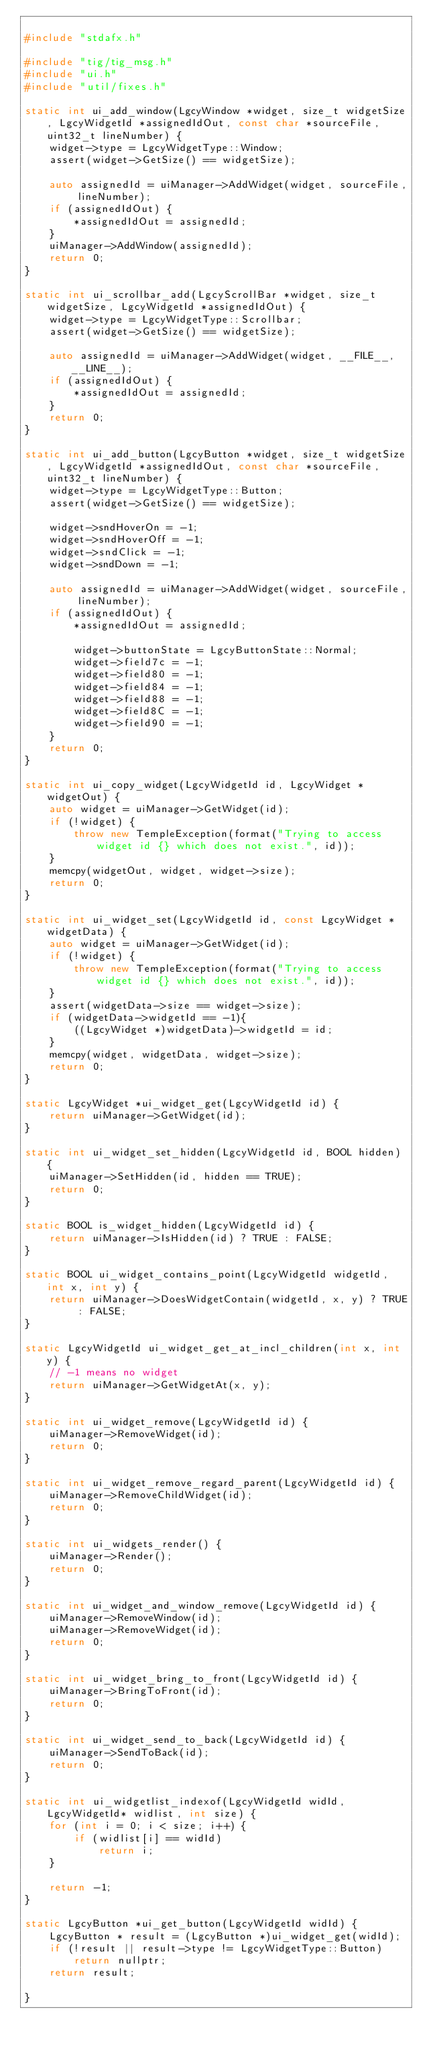Convert code to text. <code><loc_0><loc_0><loc_500><loc_500><_C++_>
#include "stdafx.h"

#include "tig/tig_msg.h"
#include "ui.h"
#include "util/fixes.h"

static int ui_add_window(LgcyWindow *widget, size_t widgetSize, LgcyWidgetId *assignedIdOut, const char *sourceFile, uint32_t lineNumber) {
	widget->type = LgcyWidgetType::Window;
	assert(widget->GetSize() == widgetSize);
	
	auto assignedId = uiManager->AddWidget(widget, sourceFile, lineNumber);
	if (assignedIdOut) {
		*assignedIdOut = assignedId;
	}
	uiManager->AddWindow(assignedId);
	return 0;
}

static int ui_scrollbar_add(LgcyScrollBar *widget, size_t widgetSize, LgcyWidgetId *assignedIdOut) {
	widget->type = LgcyWidgetType::Scrollbar;
	assert(widget->GetSize() == widgetSize);

	auto assignedId = uiManager->AddWidget(widget, __FILE__, __LINE__);
	if (assignedIdOut) {
		*assignedIdOut = assignedId;
	}
	return 0;
}

static int ui_add_button(LgcyButton *widget, size_t widgetSize, LgcyWidgetId *assignedIdOut, const char *sourceFile, uint32_t lineNumber) {
	widget->type = LgcyWidgetType::Button;
	assert(widget->GetSize() == widgetSize);

	widget->sndHoverOn = -1;
	widget->sndHoverOff = -1;
	widget->sndClick = -1;
	widget->sndDown = -1;

	auto assignedId = uiManager->AddWidget(widget, sourceFile, lineNumber);
	if (assignedIdOut) {
		*assignedIdOut = assignedId;

		widget->buttonState = LgcyButtonState::Normal;
		widget->field7c = -1;
		widget->field80 = -1;
		widget->field84 = -1;
		widget->field88 = -1;
		widget->field8C = -1;
		widget->field90 = -1;
	}
	return 0;
}

static int ui_copy_widget(LgcyWidgetId id, LgcyWidget *widgetOut) {
	auto widget = uiManager->GetWidget(id);
	if (!widget) {
		throw new TempleException(format("Trying to access widget id {} which does not exist.", id));
	}
	memcpy(widgetOut, widget, widget->size);
	return 0;
}

static int ui_widget_set(LgcyWidgetId id, const LgcyWidget *widgetData) {
	auto widget = uiManager->GetWidget(id);
	if (!widget) {
		throw new TempleException(format("Trying to access widget id {} which does not exist.", id));
	}
	assert(widgetData->size == widget->size);
	if (widgetData->widgetId == -1){
		((LgcyWidget *)widgetData)->widgetId = id;
	}
	memcpy(widget, widgetData, widget->size);
	return 0;
}

static LgcyWidget *ui_widget_get(LgcyWidgetId id) {
	return uiManager->GetWidget(id);
}

static int ui_widget_set_hidden(LgcyWidgetId id, BOOL hidden) {
	uiManager->SetHidden(id, hidden == TRUE);
	return 0;
}

static BOOL is_widget_hidden(LgcyWidgetId id) {
	return uiManager->IsHidden(id) ? TRUE : FALSE;
}

static BOOL ui_widget_contains_point(LgcyWidgetId widgetId, int x, int y) {
	return uiManager->DoesWidgetContain(widgetId, x, y) ? TRUE : FALSE;
}

static LgcyWidgetId ui_widget_get_at_incl_children(int x, int y) {
	// -1 means no widget
	return uiManager->GetWidgetAt(x, y);	
}

static int ui_widget_remove(LgcyWidgetId id) {
	uiManager->RemoveWidget(id);
	return 0;
}

static int ui_widget_remove_regard_parent(LgcyWidgetId id) {
	uiManager->RemoveChildWidget(id);
	return 0;
}

static int ui_widgets_render() {
	uiManager->Render();
	return 0;
}

static int ui_widget_and_window_remove(LgcyWidgetId id) {
	uiManager->RemoveWindow(id);
	uiManager->RemoveWidget(id);
	return 0;
}

static int ui_widget_bring_to_front(LgcyWidgetId id) {
	uiManager->BringToFront(id);
	return 0;
}

static int ui_widget_send_to_back(LgcyWidgetId id) {
	uiManager->SendToBack(id);
	return 0;
}

static int ui_widgetlist_indexof(LgcyWidgetId widId, LgcyWidgetId* widlist, int size) {
	for (int i = 0; i < size; i++) {
		if (widlist[i] == widId)
			return i;
	}

	return -1;
}

static LgcyButton *ui_get_button(LgcyWidgetId widId) {
	LgcyButton * result = (LgcyButton *)ui_widget_get(widId);
	if (!result || result->type != LgcyWidgetType::Button)
		return nullptr;
	return result;

}
</code> 